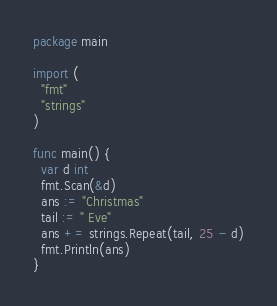<code> <loc_0><loc_0><loc_500><loc_500><_Go_>package main

import (
  "fmt"
  "strings"
)

func main() {
  var d int
  fmt.Scan(&d)
  ans := "Christmas"
  tail := " Eve"
  ans += strings.Repeat(tail, 25 - d)
  fmt.Println(ans)
}</code> 